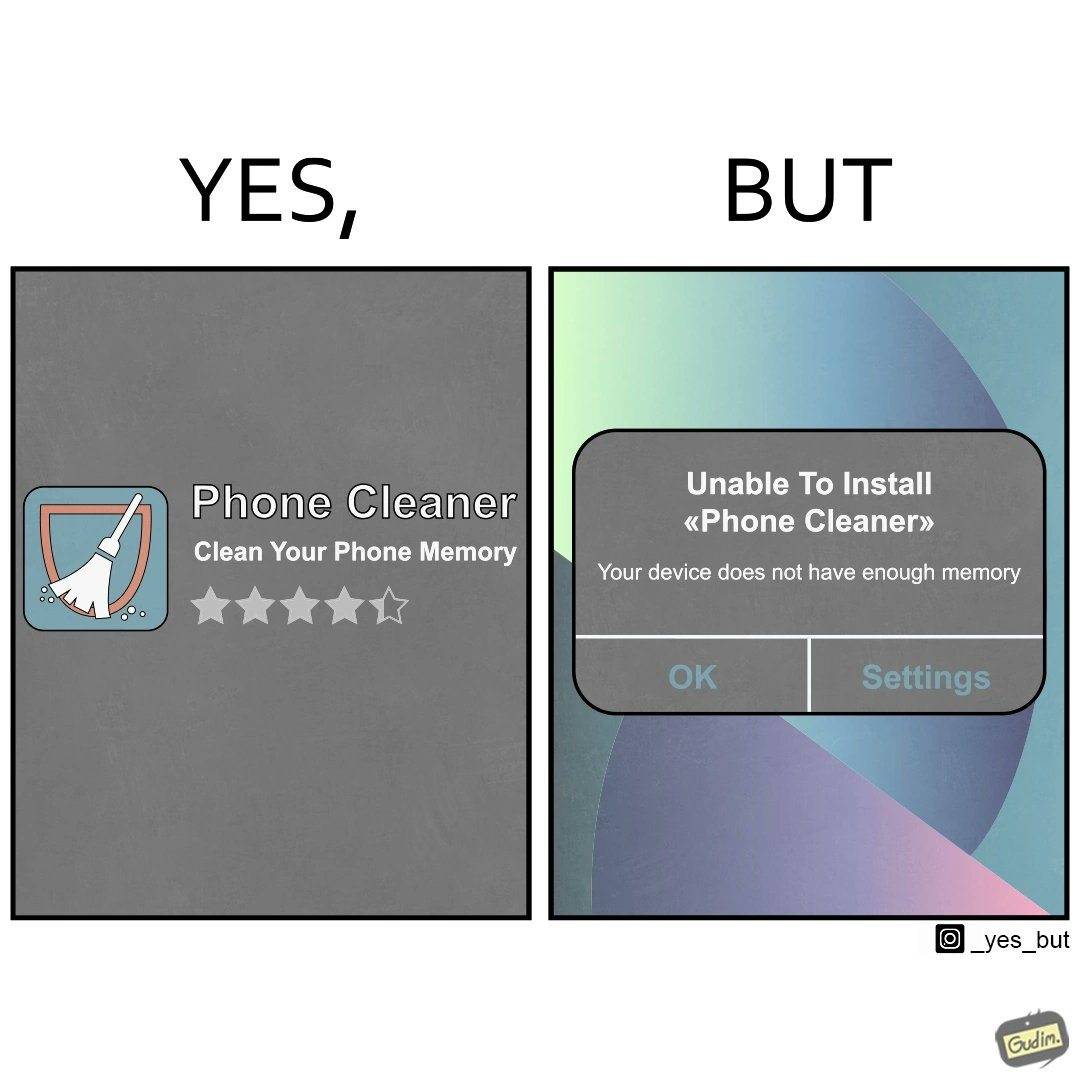Is this a satirical image? Yes, this image is satirical. 